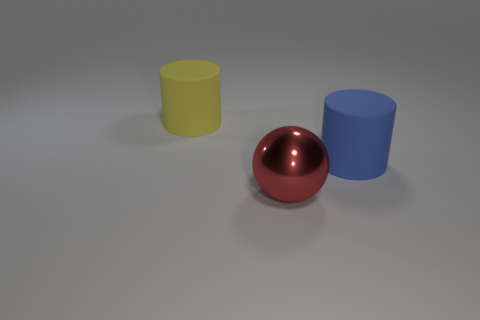What is the color of the large ball?
Keep it short and to the point. Red. How many things are either purple cubes or big yellow rubber objects?
Provide a short and direct response. 1. There is a red sphere that is the same size as the yellow object; what is it made of?
Keep it short and to the point. Metal. There is a cylinder left of the large red metal object; what is its size?
Keep it short and to the point. Large. What material is the yellow thing?
Provide a succinct answer. Rubber. What number of things are either large matte cylinders that are right of the red object or big rubber cylinders that are to the left of the big red metal object?
Your answer should be very brief. 2. How many other objects are there of the same color as the large metallic thing?
Your answer should be compact. 0. There is a metallic object; is it the same shape as the big rubber object to the left of the ball?
Make the answer very short. No. Are there fewer big matte cylinders that are in front of the shiny thing than big metal things behind the blue cylinder?
Your response must be concise. No. There is a big yellow object that is the same shape as the blue matte object; what is its material?
Make the answer very short. Rubber. 